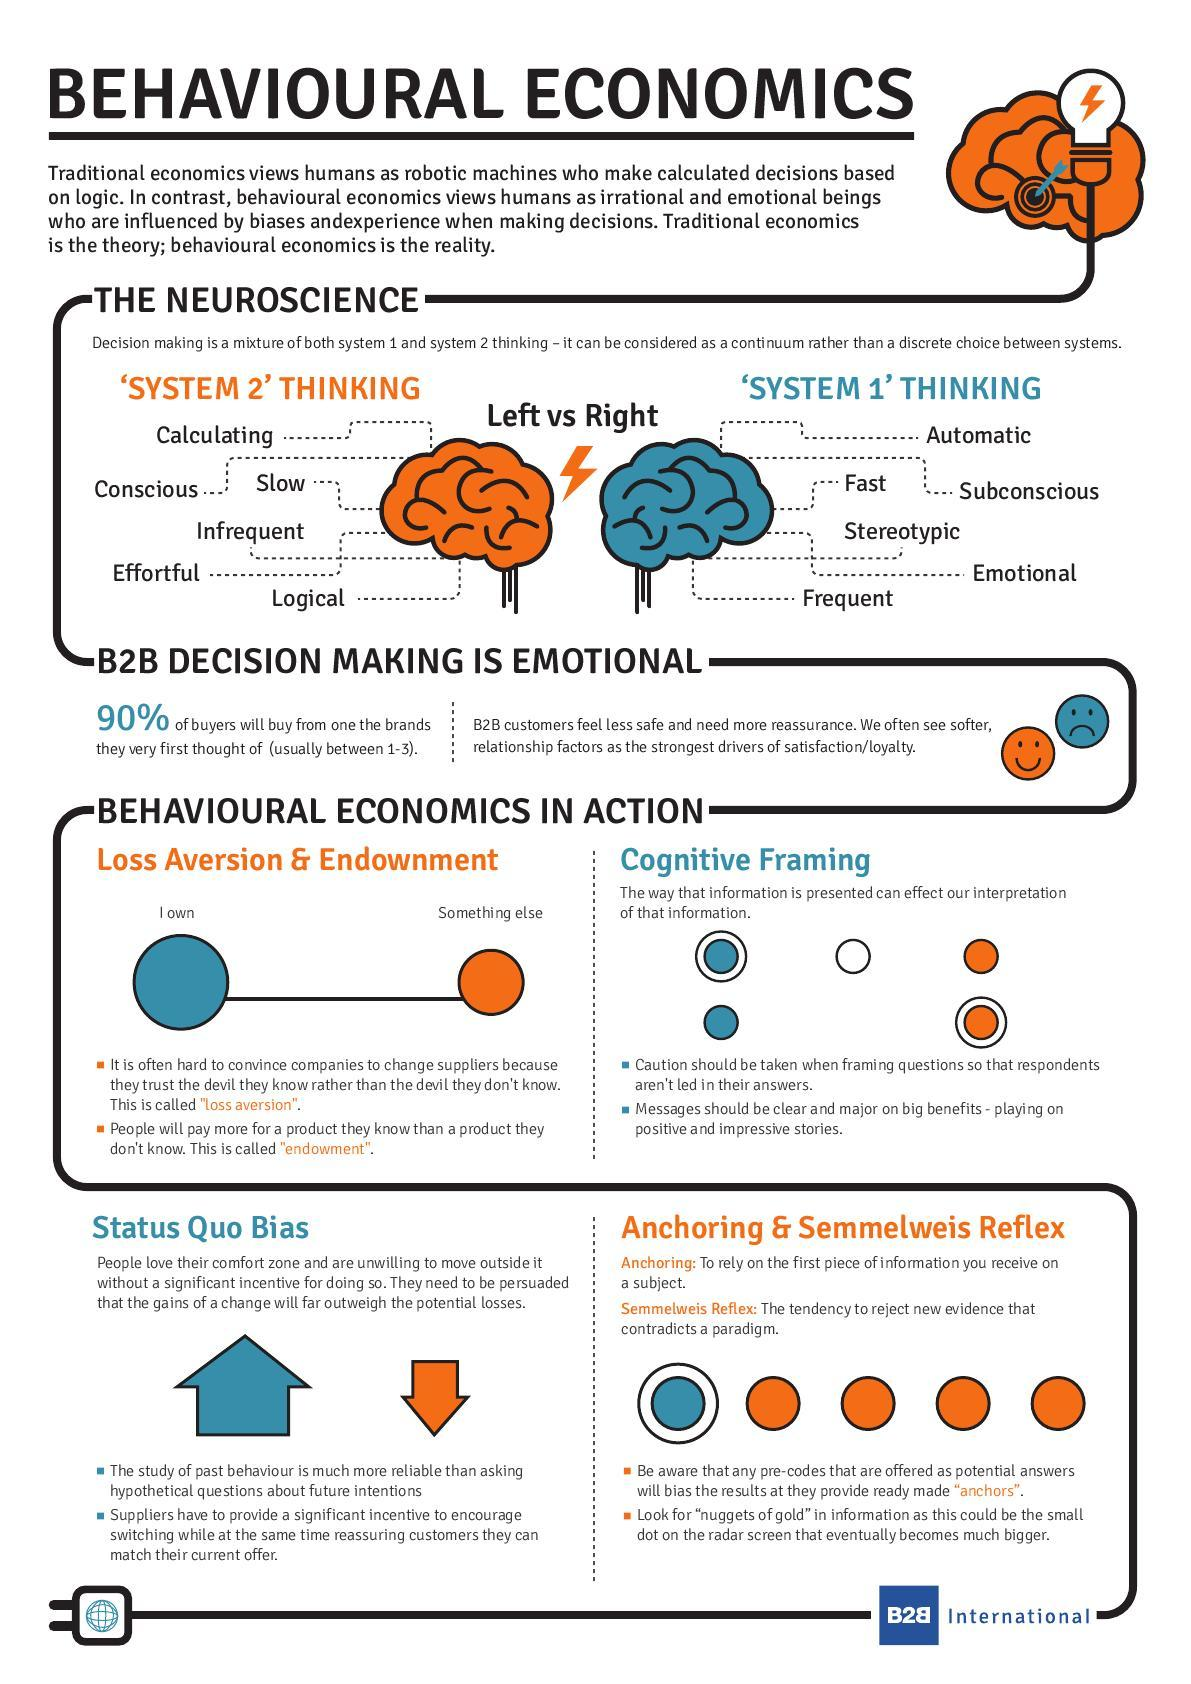How many features of System 2 Thinking are listed?
Answer the question with a short phrase. 6 What percentage of buyers do not purchase items from a brand which they thought about first? 10 Which side/part of the brain is considered as System 1 Thinking? Right Which brain system is taking care of behaviours like Frequent, Automatic, Fast? 'SYSTEM 1' THINKING Which brain system is taking care of behaviours like conscious, slow , logical? 'SYSTEM 2' THINKING Which side/part of the brain is considered as System 2 Thinking? Left 